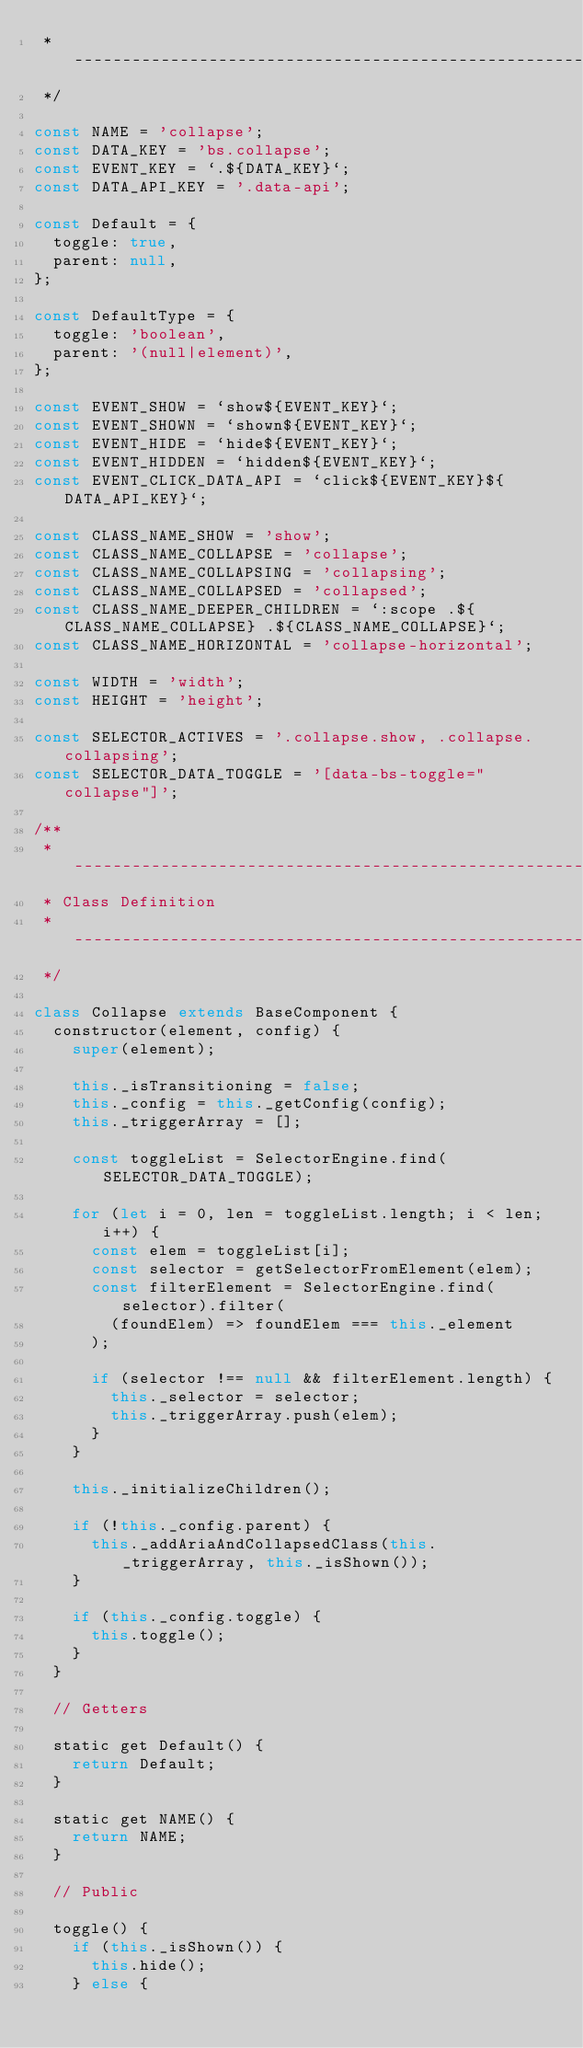<code> <loc_0><loc_0><loc_500><loc_500><_JavaScript_> * ------------------------------------------------------------------------
 */

const NAME = 'collapse';
const DATA_KEY = 'bs.collapse';
const EVENT_KEY = `.${DATA_KEY}`;
const DATA_API_KEY = '.data-api';

const Default = {
  toggle: true,
  parent: null,
};

const DefaultType = {
  toggle: 'boolean',
  parent: '(null|element)',
};

const EVENT_SHOW = `show${EVENT_KEY}`;
const EVENT_SHOWN = `shown${EVENT_KEY}`;
const EVENT_HIDE = `hide${EVENT_KEY}`;
const EVENT_HIDDEN = `hidden${EVENT_KEY}`;
const EVENT_CLICK_DATA_API = `click${EVENT_KEY}${DATA_API_KEY}`;

const CLASS_NAME_SHOW = 'show';
const CLASS_NAME_COLLAPSE = 'collapse';
const CLASS_NAME_COLLAPSING = 'collapsing';
const CLASS_NAME_COLLAPSED = 'collapsed';
const CLASS_NAME_DEEPER_CHILDREN = `:scope .${CLASS_NAME_COLLAPSE} .${CLASS_NAME_COLLAPSE}`;
const CLASS_NAME_HORIZONTAL = 'collapse-horizontal';

const WIDTH = 'width';
const HEIGHT = 'height';

const SELECTOR_ACTIVES = '.collapse.show, .collapse.collapsing';
const SELECTOR_DATA_TOGGLE = '[data-bs-toggle="collapse"]';

/**
 * ------------------------------------------------------------------------
 * Class Definition
 * ------------------------------------------------------------------------
 */

class Collapse extends BaseComponent {
  constructor(element, config) {
    super(element);

    this._isTransitioning = false;
    this._config = this._getConfig(config);
    this._triggerArray = [];

    const toggleList = SelectorEngine.find(SELECTOR_DATA_TOGGLE);

    for (let i = 0, len = toggleList.length; i < len; i++) {
      const elem = toggleList[i];
      const selector = getSelectorFromElement(elem);
      const filterElement = SelectorEngine.find(selector).filter(
        (foundElem) => foundElem === this._element
      );

      if (selector !== null && filterElement.length) {
        this._selector = selector;
        this._triggerArray.push(elem);
      }
    }

    this._initializeChildren();

    if (!this._config.parent) {
      this._addAriaAndCollapsedClass(this._triggerArray, this._isShown());
    }

    if (this._config.toggle) {
      this.toggle();
    }
  }

  // Getters

  static get Default() {
    return Default;
  }

  static get NAME() {
    return NAME;
  }

  // Public

  toggle() {
    if (this._isShown()) {
      this.hide();
    } else {</code> 